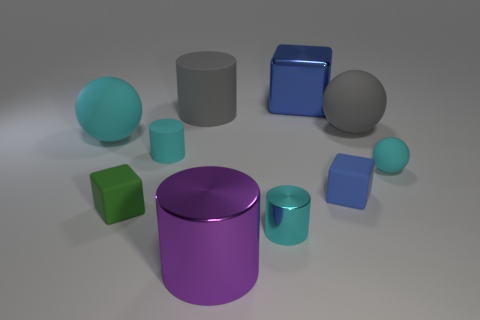Subtract all cyan balls. Subtract all purple cubes. How many balls are left? 1 Subtract all cylinders. How many objects are left? 6 Subtract 0 purple blocks. How many objects are left? 10 Subtract all big gray balls. Subtract all large brown metal spheres. How many objects are left? 9 Add 7 gray rubber balls. How many gray rubber balls are left? 8 Add 4 big blue cubes. How many big blue cubes exist? 5 